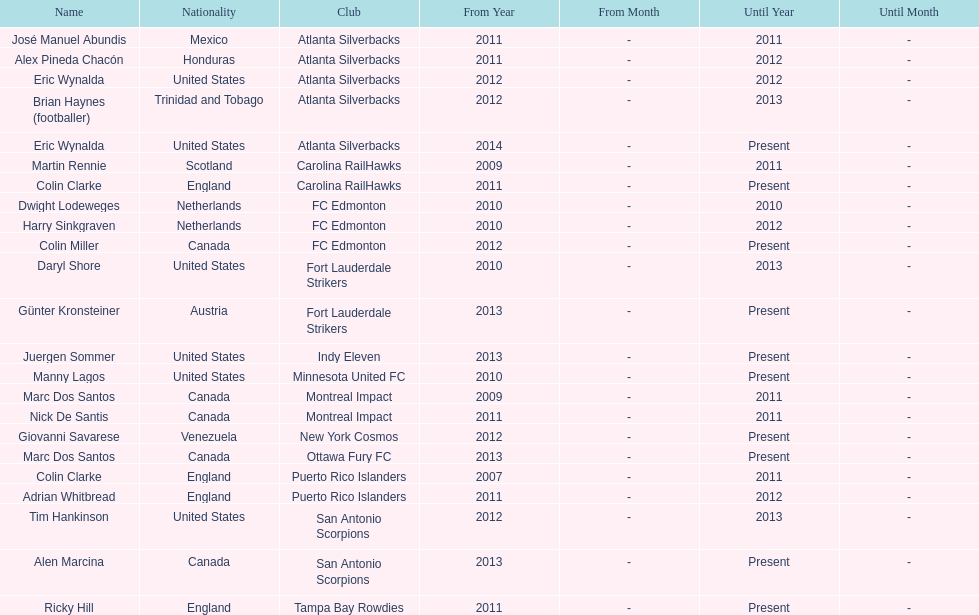What same country did marc dos santos coach as colin miller? Canada. 